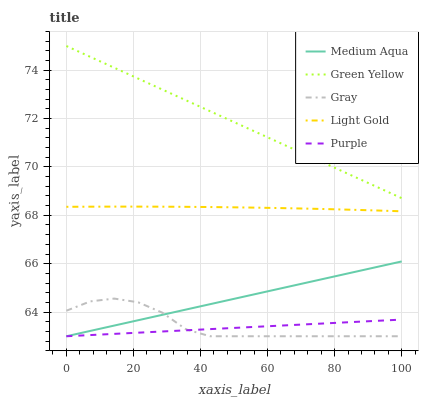Does Purple have the minimum area under the curve?
Answer yes or no. Yes. Does Green Yellow have the maximum area under the curve?
Answer yes or no. Yes. Does Gray have the minimum area under the curve?
Answer yes or no. No. Does Gray have the maximum area under the curve?
Answer yes or no. No. Is Purple the smoothest?
Answer yes or no. Yes. Is Gray the roughest?
Answer yes or no. Yes. Is Green Yellow the smoothest?
Answer yes or no. No. Is Green Yellow the roughest?
Answer yes or no. No. Does Purple have the lowest value?
Answer yes or no. Yes. Does Green Yellow have the lowest value?
Answer yes or no. No. Does Green Yellow have the highest value?
Answer yes or no. Yes. Does Gray have the highest value?
Answer yes or no. No. Is Medium Aqua less than Green Yellow?
Answer yes or no. Yes. Is Light Gold greater than Medium Aqua?
Answer yes or no. Yes. Does Purple intersect Medium Aqua?
Answer yes or no. Yes. Is Purple less than Medium Aqua?
Answer yes or no. No. Is Purple greater than Medium Aqua?
Answer yes or no. No. Does Medium Aqua intersect Green Yellow?
Answer yes or no. No. 